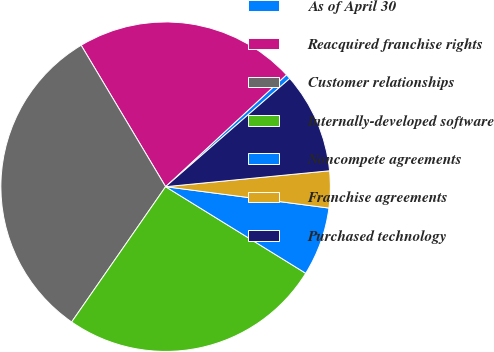Convert chart. <chart><loc_0><loc_0><loc_500><loc_500><pie_chart><fcel>As of April 30<fcel>Reacquired franchise rights<fcel>Customer relationships<fcel>Internally-developed software<fcel>Noncompete agreements<fcel>Franchise agreements<fcel>Purchased technology<nl><fcel>0.48%<fcel>21.68%<fcel>31.77%<fcel>25.85%<fcel>6.74%<fcel>3.61%<fcel>9.87%<nl></chart> 